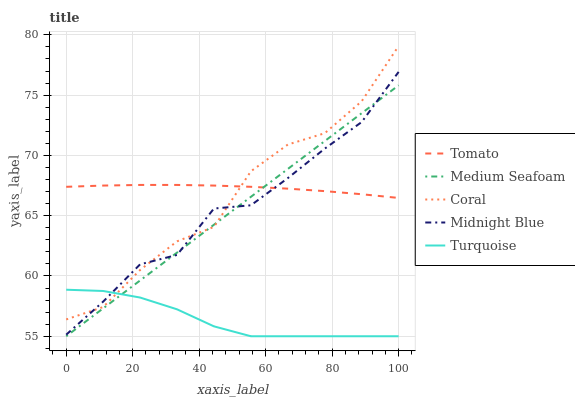Does Turquoise have the minimum area under the curve?
Answer yes or no. Yes. Does Tomato have the maximum area under the curve?
Answer yes or no. Yes. Does Coral have the minimum area under the curve?
Answer yes or no. No. Does Coral have the maximum area under the curve?
Answer yes or no. No. Is Medium Seafoam the smoothest?
Answer yes or no. Yes. Is Coral the roughest?
Answer yes or no. Yes. Is Turquoise the smoothest?
Answer yes or no. No. Is Turquoise the roughest?
Answer yes or no. No. Does Turquoise have the lowest value?
Answer yes or no. Yes. Does Coral have the lowest value?
Answer yes or no. No. Does Coral have the highest value?
Answer yes or no. Yes. Does Turquoise have the highest value?
Answer yes or no. No. Is Turquoise less than Tomato?
Answer yes or no. Yes. Is Tomato greater than Turquoise?
Answer yes or no. Yes. Does Coral intersect Turquoise?
Answer yes or no. Yes. Is Coral less than Turquoise?
Answer yes or no. No. Is Coral greater than Turquoise?
Answer yes or no. No. Does Turquoise intersect Tomato?
Answer yes or no. No. 